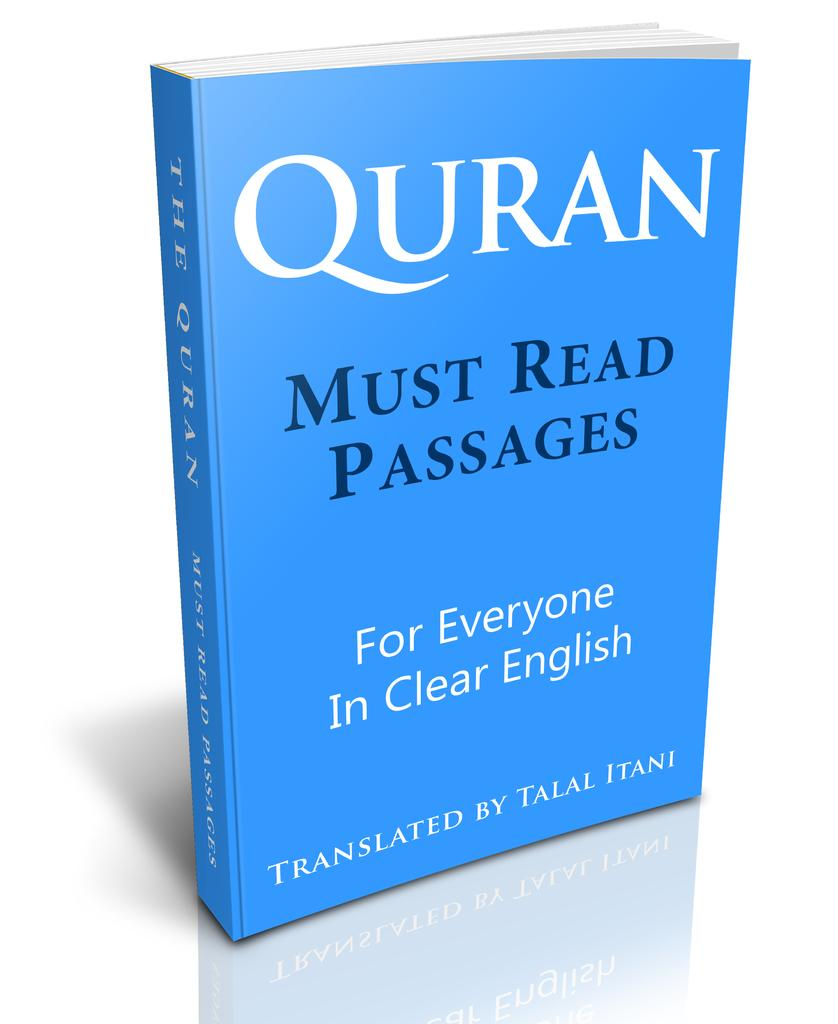Provide a one-sentence caption for the provided image. blue copy of quran in english standing upright against white background. 